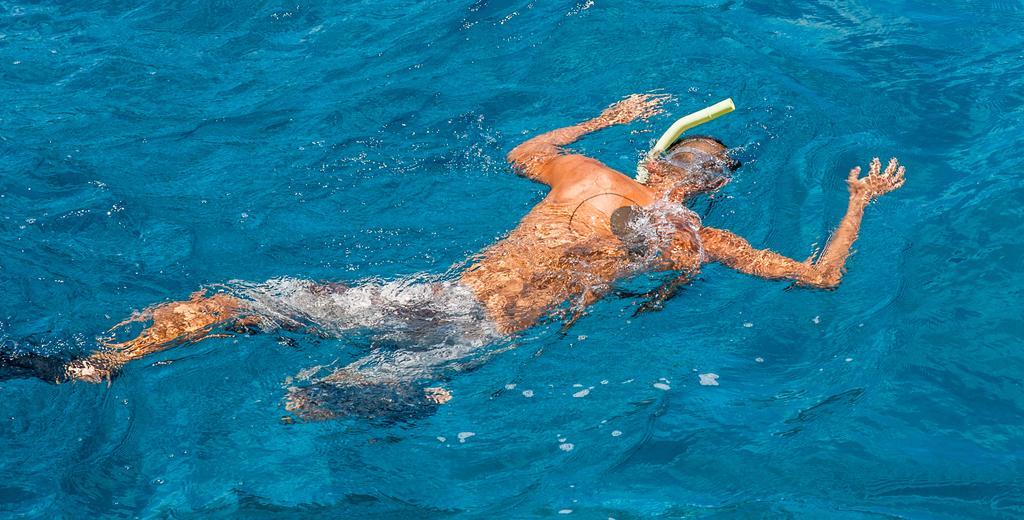Describe this image in one or two sentences. In this picture I can see a human in the water. 